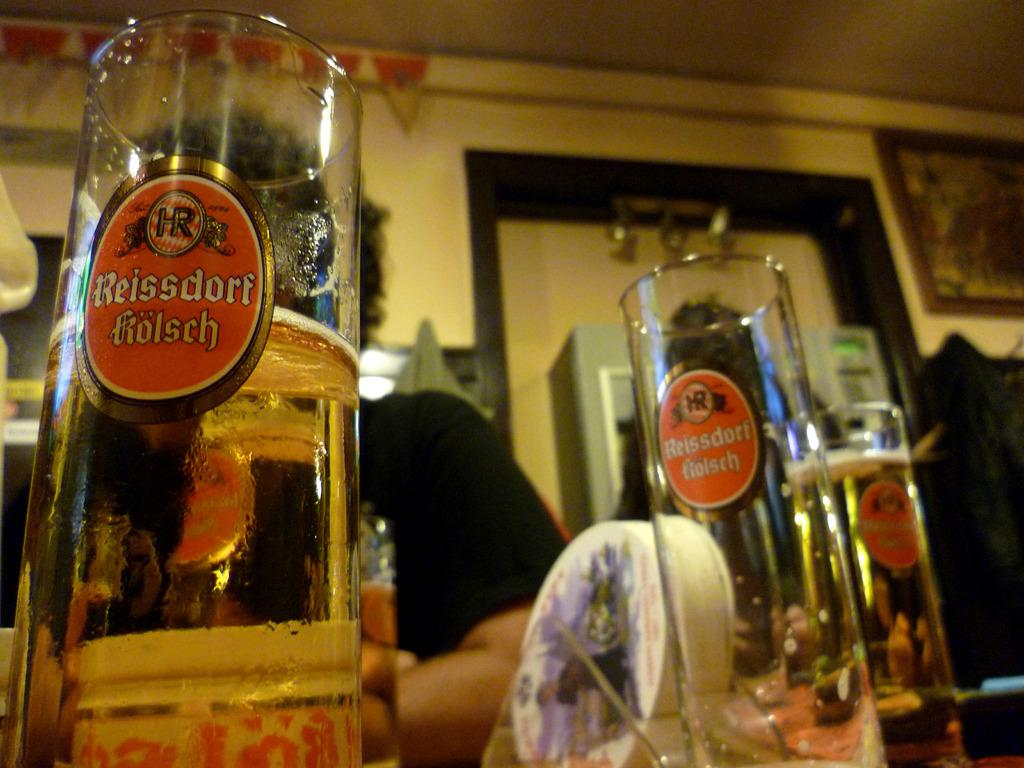<image>
Render a clear and concise summary of the photo. A picture of glasses with the name Reissdorf Kolsch on them. 